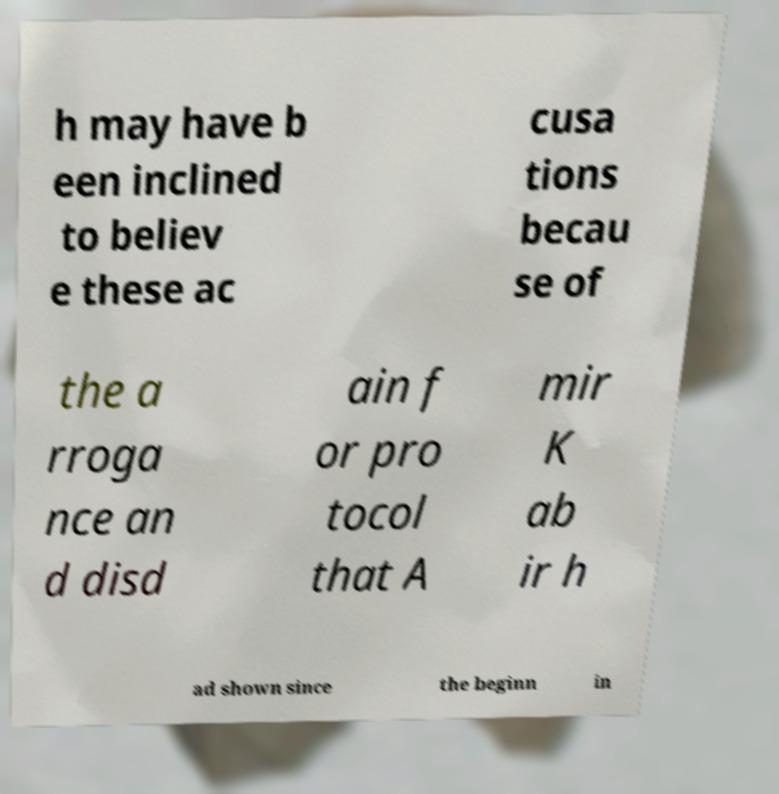Could you assist in decoding the text presented in this image and type it out clearly? h may have b een inclined to believ e these ac cusa tions becau se of the a rroga nce an d disd ain f or pro tocol that A mir K ab ir h ad shown since the beginn in 